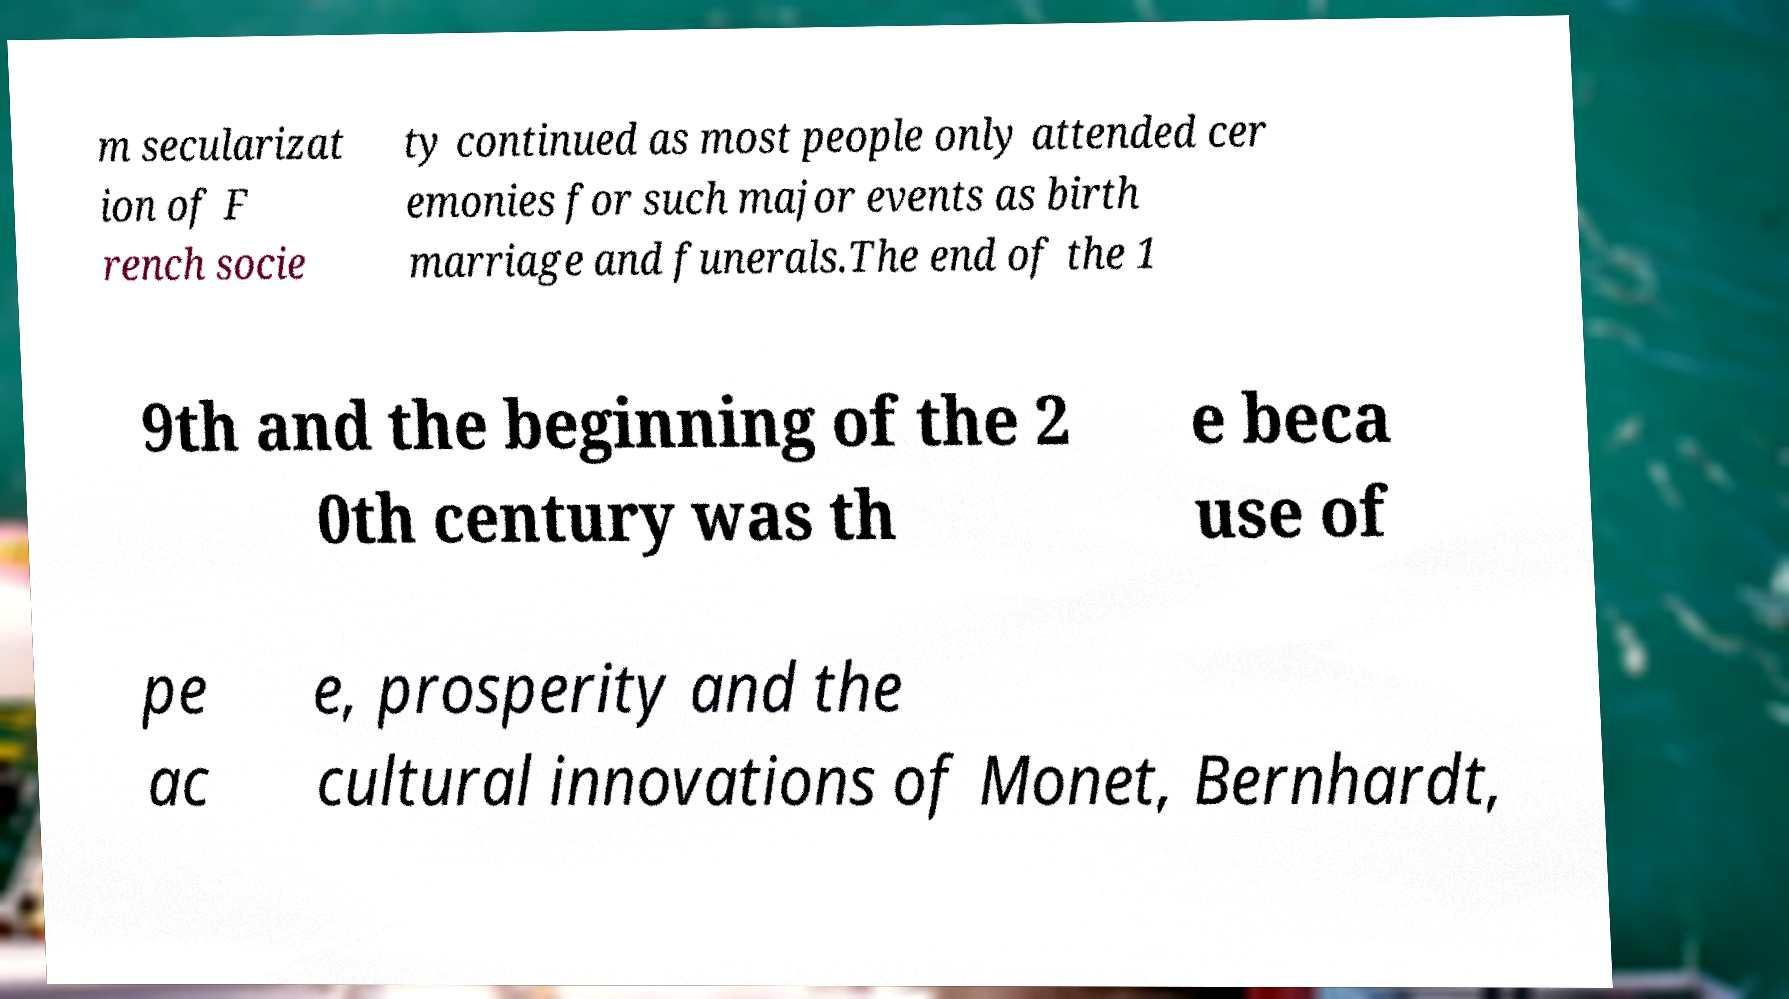Can you accurately transcribe the text from the provided image for me? m secularizat ion of F rench socie ty continued as most people only attended cer emonies for such major events as birth marriage and funerals.The end of the 1 9th and the beginning of the 2 0th century was th e beca use of pe ac e, prosperity and the cultural innovations of Monet, Bernhardt, 